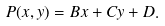<formula> <loc_0><loc_0><loc_500><loc_500>P ( x , y ) = B x + C y + D .</formula> 